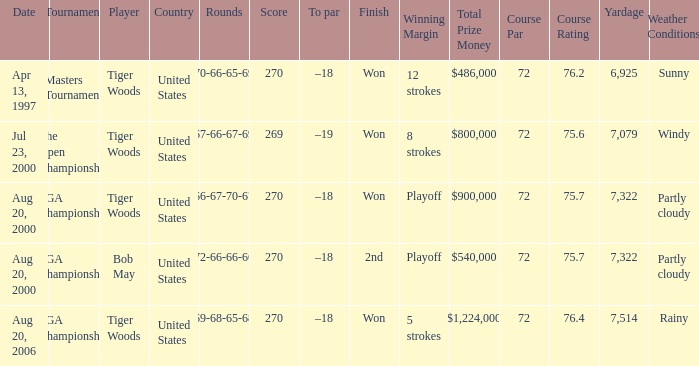What country hosts the tournament the open championship? United States. 